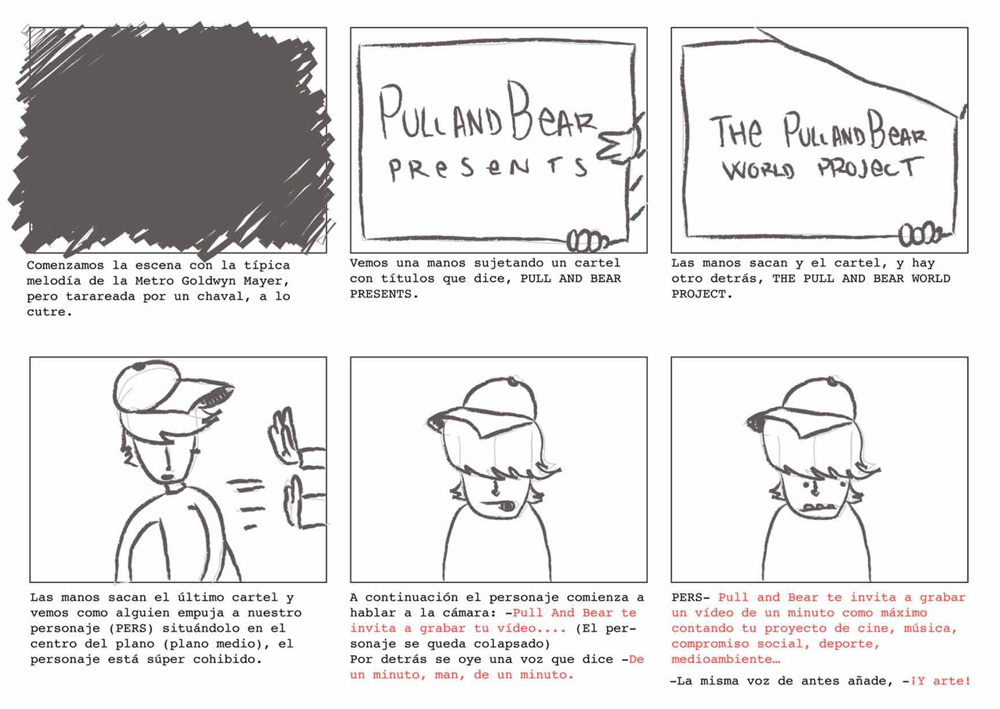What is the emotional expression of the character when he is finally revealed in the comic strip, and what might this suggest about his attitude towards the project he is presenting? The character's emotional expression is marked by shyness and modesty, as evidenced by his slightly blushed cheeks and avoided gaze. This suggests he may feel somewhat anxious or self-conscious about the significance of his presentation, reflecting an underlying hesitance or vulnerability about his role. Despite this, his participation and initiative in revealing the project also signal a commitment to this endeavor, suggesting his attitude combines a mix of reluctance and determination to engage his audience in what appears to be an artistic project. 